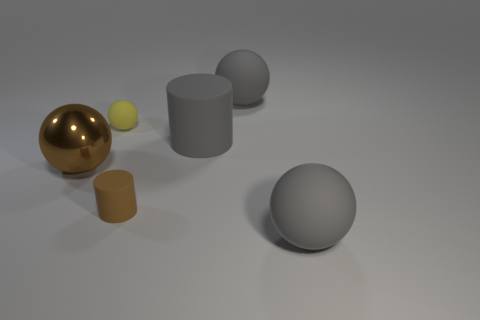Add 2 small brown things. How many objects exist? 8 Subtract all blue balls. Subtract all gray cylinders. How many balls are left? 4 Subtract all balls. How many objects are left? 2 Add 5 yellow matte things. How many yellow matte things exist? 6 Subtract 1 gray cylinders. How many objects are left? 5 Subtract all gray rubber cylinders. Subtract all gray rubber balls. How many objects are left? 3 Add 2 balls. How many balls are left? 6 